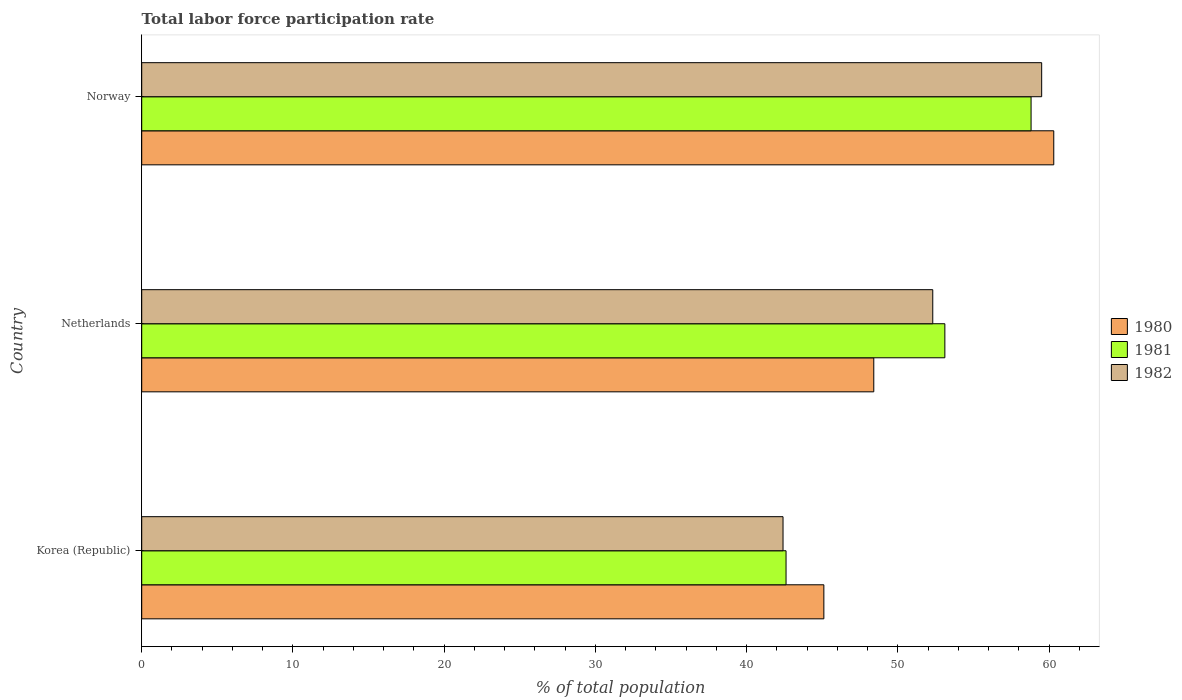How many groups of bars are there?
Keep it short and to the point. 3. How many bars are there on the 3rd tick from the top?
Your answer should be very brief. 3. How many bars are there on the 3rd tick from the bottom?
Offer a very short reply. 3. What is the total labor force participation rate in 1980 in Korea (Republic)?
Provide a succinct answer. 45.1. Across all countries, what is the maximum total labor force participation rate in 1980?
Your response must be concise. 60.3. Across all countries, what is the minimum total labor force participation rate in 1982?
Keep it short and to the point. 42.4. In which country was the total labor force participation rate in 1980 maximum?
Offer a very short reply. Norway. In which country was the total labor force participation rate in 1982 minimum?
Provide a succinct answer. Korea (Republic). What is the total total labor force participation rate in 1981 in the graph?
Your answer should be very brief. 154.5. What is the difference between the total labor force participation rate in 1981 in Netherlands and that in Norway?
Your response must be concise. -5.7. What is the average total labor force participation rate in 1982 per country?
Your answer should be very brief. 51.4. What is the difference between the total labor force participation rate in 1981 and total labor force participation rate in 1980 in Norway?
Provide a short and direct response. -1.5. What is the ratio of the total labor force participation rate in 1980 in Korea (Republic) to that in Norway?
Provide a succinct answer. 0.75. What is the difference between the highest and the second highest total labor force participation rate in 1981?
Ensure brevity in your answer.  5.7. What is the difference between the highest and the lowest total labor force participation rate in 1982?
Make the answer very short. 17.1. Is the sum of the total labor force participation rate in 1982 in Korea (Republic) and Netherlands greater than the maximum total labor force participation rate in 1980 across all countries?
Your answer should be compact. Yes. What does the 3rd bar from the top in Korea (Republic) represents?
Make the answer very short. 1980. How many bars are there?
Your answer should be very brief. 9. How many countries are there in the graph?
Ensure brevity in your answer.  3. Are the values on the major ticks of X-axis written in scientific E-notation?
Your answer should be compact. No. Does the graph contain any zero values?
Your answer should be very brief. No. Where does the legend appear in the graph?
Your response must be concise. Center right. How are the legend labels stacked?
Provide a succinct answer. Vertical. What is the title of the graph?
Keep it short and to the point. Total labor force participation rate. Does "1976" appear as one of the legend labels in the graph?
Give a very brief answer. No. What is the label or title of the X-axis?
Provide a short and direct response. % of total population. What is the % of total population in 1980 in Korea (Republic)?
Your response must be concise. 45.1. What is the % of total population of 1981 in Korea (Republic)?
Provide a short and direct response. 42.6. What is the % of total population of 1982 in Korea (Republic)?
Your response must be concise. 42.4. What is the % of total population in 1980 in Netherlands?
Give a very brief answer. 48.4. What is the % of total population in 1981 in Netherlands?
Ensure brevity in your answer.  53.1. What is the % of total population of 1982 in Netherlands?
Your answer should be compact. 52.3. What is the % of total population of 1980 in Norway?
Keep it short and to the point. 60.3. What is the % of total population of 1981 in Norway?
Your answer should be compact. 58.8. What is the % of total population of 1982 in Norway?
Give a very brief answer. 59.5. Across all countries, what is the maximum % of total population of 1980?
Give a very brief answer. 60.3. Across all countries, what is the maximum % of total population in 1981?
Your answer should be compact. 58.8. Across all countries, what is the maximum % of total population in 1982?
Your response must be concise. 59.5. Across all countries, what is the minimum % of total population of 1980?
Offer a very short reply. 45.1. Across all countries, what is the minimum % of total population in 1981?
Keep it short and to the point. 42.6. Across all countries, what is the minimum % of total population of 1982?
Provide a short and direct response. 42.4. What is the total % of total population in 1980 in the graph?
Your answer should be very brief. 153.8. What is the total % of total population in 1981 in the graph?
Ensure brevity in your answer.  154.5. What is the total % of total population in 1982 in the graph?
Your answer should be very brief. 154.2. What is the difference between the % of total population in 1981 in Korea (Republic) and that in Netherlands?
Your response must be concise. -10.5. What is the difference between the % of total population in 1980 in Korea (Republic) and that in Norway?
Offer a very short reply. -15.2. What is the difference between the % of total population in 1981 in Korea (Republic) and that in Norway?
Your answer should be very brief. -16.2. What is the difference between the % of total population of 1982 in Korea (Republic) and that in Norway?
Offer a very short reply. -17.1. What is the difference between the % of total population of 1980 in Netherlands and that in Norway?
Offer a terse response. -11.9. What is the difference between the % of total population of 1981 in Netherlands and that in Norway?
Offer a terse response. -5.7. What is the difference between the % of total population of 1980 in Korea (Republic) and the % of total population of 1982 in Netherlands?
Your answer should be compact. -7.2. What is the difference between the % of total population in 1980 in Korea (Republic) and the % of total population in 1981 in Norway?
Your answer should be compact. -13.7. What is the difference between the % of total population of 1980 in Korea (Republic) and the % of total population of 1982 in Norway?
Provide a succinct answer. -14.4. What is the difference between the % of total population of 1981 in Korea (Republic) and the % of total population of 1982 in Norway?
Offer a very short reply. -16.9. What is the difference between the % of total population in 1980 in Netherlands and the % of total population in 1981 in Norway?
Offer a terse response. -10.4. What is the difference between the % of total population in 1980 in Netherlands and the % of total population in 1982 in Norway?
Ensure brevity in your answer.  -11.1. What is the average % of total population in 1980 per country?
Your response must be concise. 51.27. What is the average % of total population of 1981 per country?
Keep it short and to the point. 51.5. What is the average % of total population of 1982 per country?
Ensure brevity in your answer.  51.4. What is the difference between the % of total population of 1980 and % of total population of 1981 in Korea (Republic)?
Provide a succinct answer. 2.5. What is the difference between the % of total population of 1980 and % of total population of 1982 in Korea (Republic)?
Your response must be concise. 2.7. What is the difference between the % of total population of 1980 and % of total population of 1982 in Netherlands?
Your answer should be very brief. -3.9. What is the difference between the % of total population in 1981 and % of total population in 1982 in Netherlands?
Keep it short and to the point. 0.8. What is the difference between the % of total population of 1980 and % of total population of 1981 in Norway?
Make the answer very short. 1.5. What is the difference between the % of total population of 1980 and % of total population of 1982 in Norway?
Ensure brevity in your answer.  0.8. What is the difference between the % of total population of 1981 and % of total population of 1982 in Norway?
Ensure brevity in your answer.  -0.7. What is the ratio of the % of total population of 1980 in Korea (Republic) to that in Netherlands?
Ensure brevity in your answer.  0.93. What is the ratio of the % of total population in 1981 in Korea (Republic) to that in Netherlands?
Give a very brief answer. 0.8. What is the ratio of the % of total population of 1982 in Korea (Republic) to that in Netherlands?
Keep it short and to the point. 0.81. What is the ratio of the % of total population of 1980 in Korea (Republic) to that in Norway?
Your response must be concise. 0.75. What is the ratio of the % of total population in 1981 in Korea (Republic) to that in Norway?
Make the answer very short. 0.72. What is the ratio of the % of total population of 1982 in Korea (Republic) to that in Norway?
Provide a succinct answer. 0.71. What is the ratio of the % of total population of 1980 in Netherlands to that in Norway?
Your answer should be very brief. 0.8. What is the ratio of the % of total population in 1981 in Netherlands to that in Norway?
Ensure brevity in your answer.  0.9. What is the ratio of the % of total population of 1982 in Netherlands to that in Norway?
Your response must be concise. 0.88. What is the difference between the highest and the second highest % of total population of 1981?
Make the answer very short. 5.7. What is the difference between the highest and the lowest % of total population in 1980?
Ensure brevity in your answer.  15.2. What is the difference between the highest and the lowest % of total population in 1981?
Ensure brevity in your answer.  16.2. 